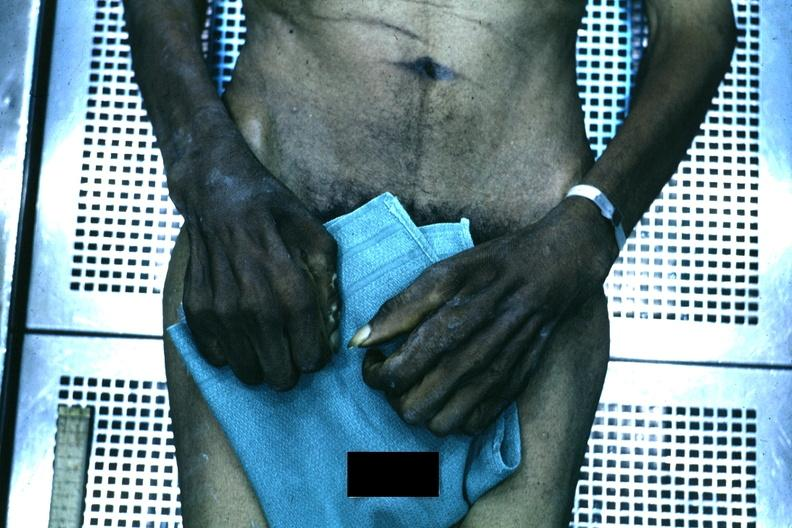s muscle atrophy present?
Answer the question using a single word or phrase. No 